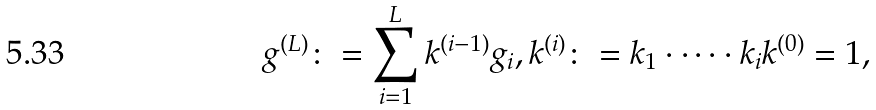Convert formula to latex. <formula><loc_0><loc_0><loc_500><loc_500>g ^ { ( L ) } \colon = \sum _ { i = 1 } ^ { L } k ^ { ( i - 1 ) } g _ { i } , k ^ { ( i ) } \colon = k _ { 1 } \cdot \dots \cdot k _ { i } k ^ { ( 0 ) } = 1 ,</formula> 